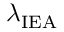Convert formula to latex. <formula><loc_0><loc_0><loc_500><loc_500>\lambda _ { I E A }</formula> 